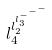<formula> <loc_0><loc_0><loc_500><loc_500>l _ { 4 } ^ { l _ { 2 } ^ { l _ { 3 } ^ { - ^ { - ^ { - } } } } }</formula> 